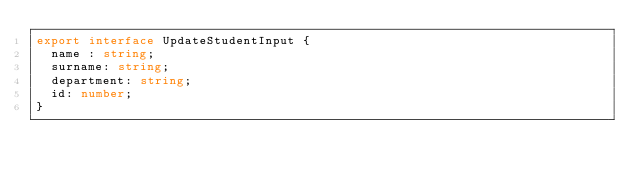<code> <loc_0><loc_0><loc_500><loc_500><_TypeScript_>export interface UpdateStudentInput {
  name : string;
  surname: string;
  department: string;
  id: number;
}
</code> 